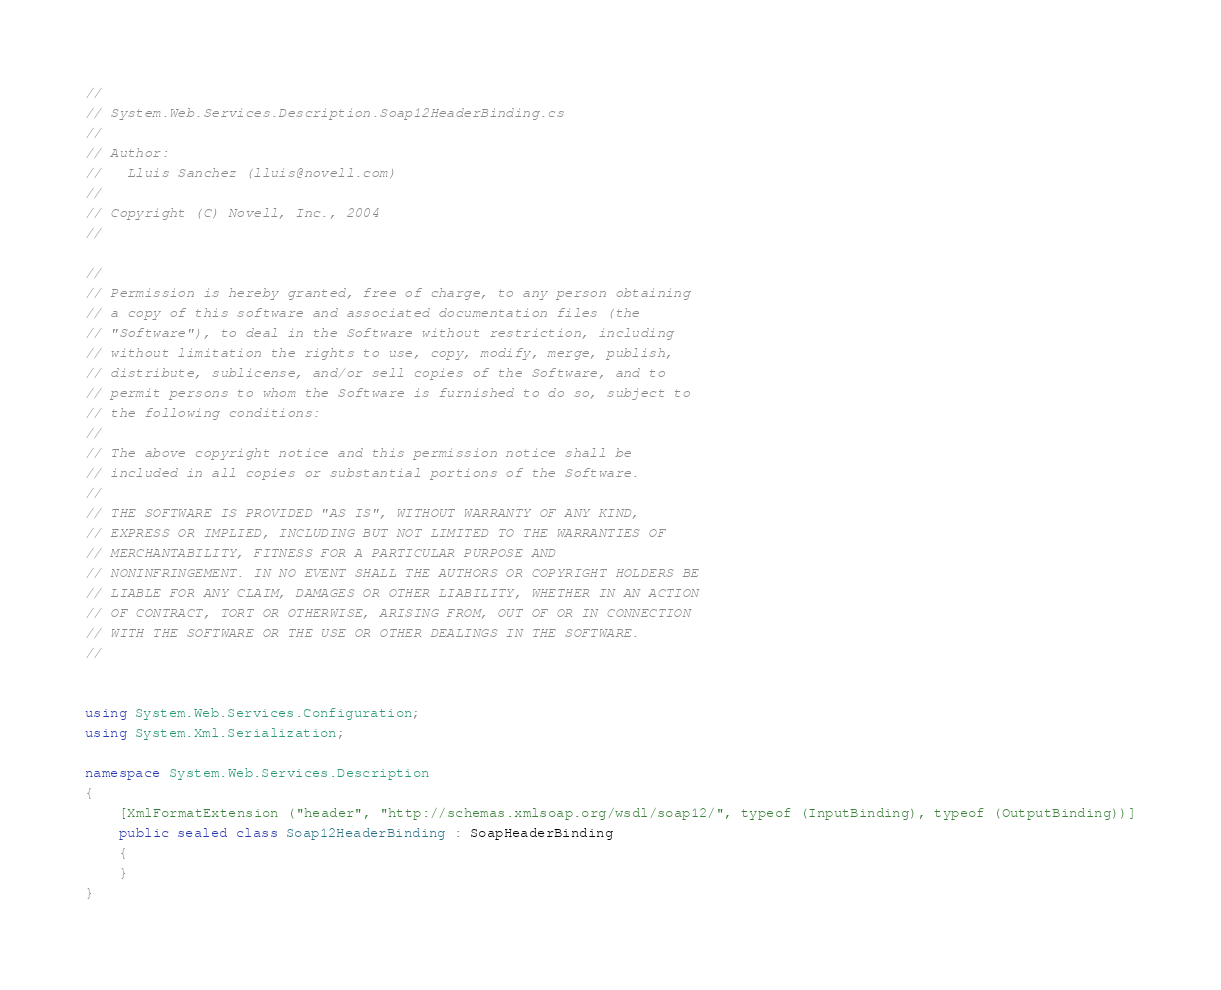<code> <loc_0><loc_0><loc_500><loc_500><_C#_>// 
// System.Web.Services.Description.Soap12HeaderBinding.cs
//
// Author:
//   Lluis Sanchez (lluis@novell.com)
//
// Copyright (C) Novell, Inc., 2004
//

//
// Permission is hereby granted, free of charge, to any person obtaining
// a copy of this software and associated documentation files (the
// "Software"), to deal in the Software without restriction, including
// without limitation the rights to use, copy, modify, merge, publish,
// distribute, sublicense, and/or sell copies of the Software, and to
// permit persons to whom the Software is furnished to do so, subject to
// the following conditions:
// 
// The above copyright notice and this permission notice shall be
// included in all copies or substantial portions of the Software.
// 
// THE SOFTWARE IS PROVIDED "AS IS", WITHOUT WARRANTY OF ANY KIND,
// EXPRESS OR IMPLIED, INCLUDING BUT NOT LIMITED TO THE WARRANTIES OF
// MERCHANTABILITY, FITNESS FOR A PARTICULAR PURPOSE AND
// NONINFRINGEMENT. IN NO EVENT SHALL THE AUTHORS OR COPYRIGHT HOLDERS BE
// LIABLE FOR ANY CLAIM, DAMAGES OR OTHER LIABILITY, WHETHER IN AN ACTION
// OF CONTRACT, TORT OR OTHERWISE, ARISING FROM, OUT OF OR IN CONNECTION
// WITH THE SOFTWARE OR THE USE OR OTHER DEALINGS IN THE SOFTWARE.
//


using System.Web.Services.Configuration;
using System.Xml.Serialization;

namespace System.Web.Services.Description 
{
	[XmlFormatExtension ("header", "http://schemas.xmlsoap.org/wsdl/soap12/", typeof (InputBinding), typeof (OutputBinding))]
	public sealed class Soap12HeaderBinding : SoapHeaderBinding 
	{
	}
}

</code> 